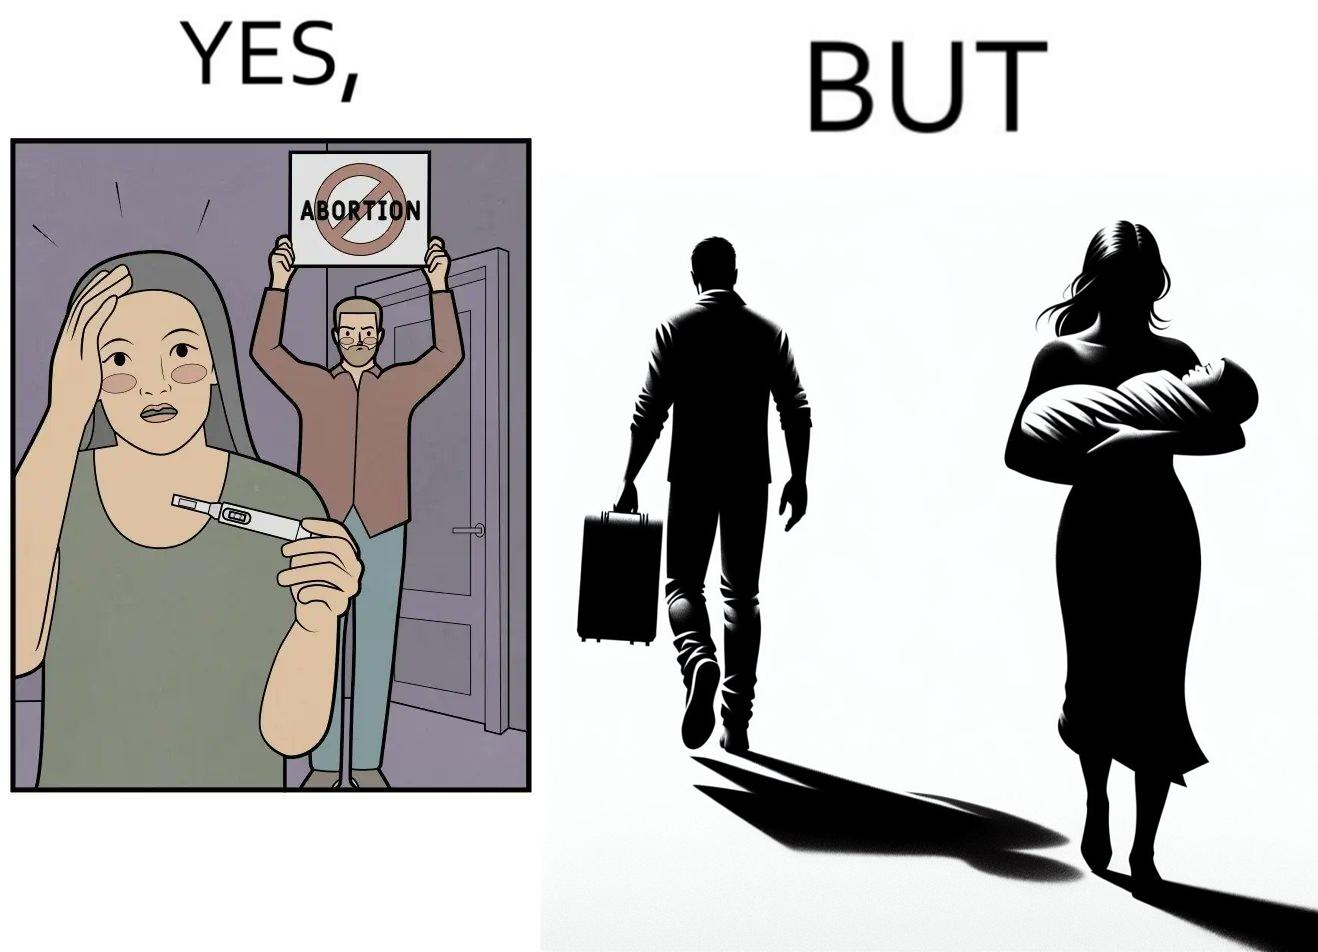Describe what you see in the left and right parts of this image. In the left part of the image: It is a woman with a pregnancy test showing positive results while a man is protesting against abortion In the right part of the image: It is a man leaving his partner alone with her baby 